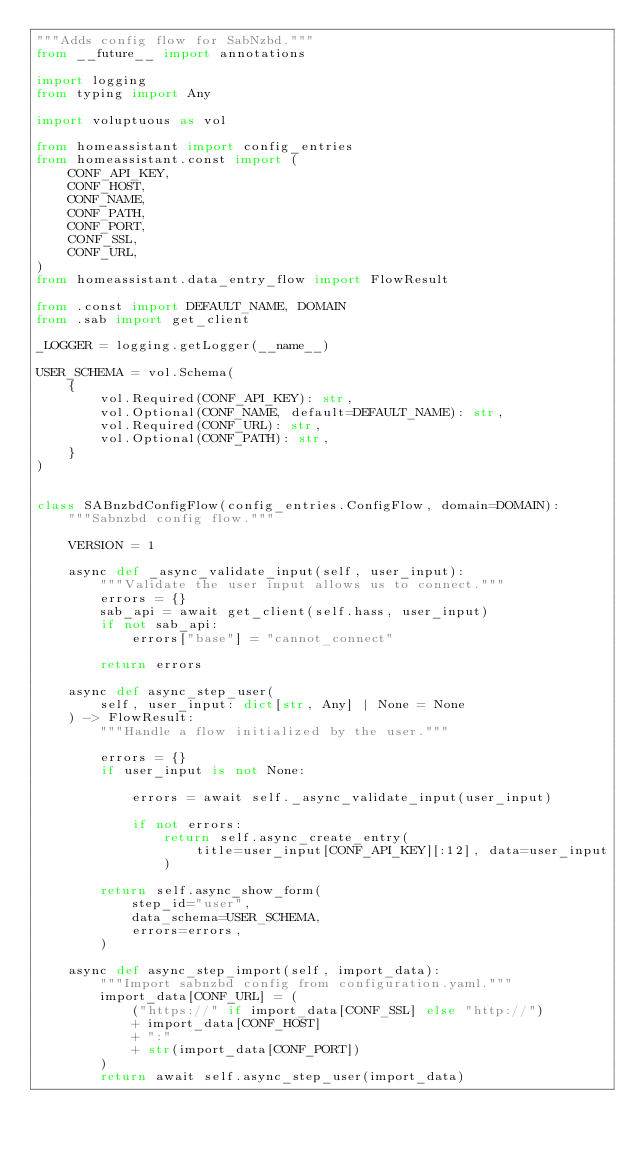Convert code to text. <code><loc_0><loc_0><loc_500><loc_500><_Python_>"""Adds config flow for SabNzbd."""
from __future__ import annotations

import logging
from typing import Any

import voluptuous as vol

from homeassistant import config_entries
from homeassistant.const import (
    CONF_API_KEY,
    CONF_HOST,
    CONF_NAME,
    CONF_PATH,
    CONF_PORT,
    CONF_SSL,
    CONF_URL,
)
from homeassistant.data_entry_flow import FlowResult

from .const import DEFAULT_NAME, DOMAIN
from .sab import get_client

_LOGGER = logging.getLogger(__name__)

USER_SCHEMA = vol.Schema(
    {
        vol.Required(CONF_API_KEY): str,
        vol.Optional(CONF_NAME, default=DEFAULT_NAME): str,
        vol.Required(CONF_URL): str,
        vol.Optional(CONF_PATH): str,
    }
)


class SABnzbdConfigFlow(config_entries.ConfigFlow, domain=DOMAIN):
    """Sabnzbd config flow."""

    VERSION = 1

    async def _async_validate_input(self, user_input):
        """Validate the user input allows us to connect."""
        errors = {}
        sab_api = await get_client(self.hass, user_input)
        if not sab_api:
            errors["base"] = "cannot_connect"

        return errors

    async def async_step_user(
        self, user_input: dict[str, Any] | None = None
    ) -> FlowResult:
        """Handle a flow initialized by the user."""

        errors = {}
        if user_input is not None:

            errors = await self._async_validate_input(user_input)

            if not errors:
                return self.async_create_entry(
                    title=user_input[CONF_API_KEY][:12], data=user_input
                )

        return self.async_show_form(
            step_id="user",
            data_schema=USER_SCHEMA,
            errors=errors,
        )

    async def async_step_import(self, import_data):
        """Import sabnzbd config from configuration.yaml."""
        import_data[CONF_URL] = (
            ("https://" if import_data[CONF_SSL] else "http://")
            + import_data[CONF_HOST]
            + ":"
            + str(import_data[CONF_PORT])
        )
        return await self.async_step_user(import_data)
</code> 